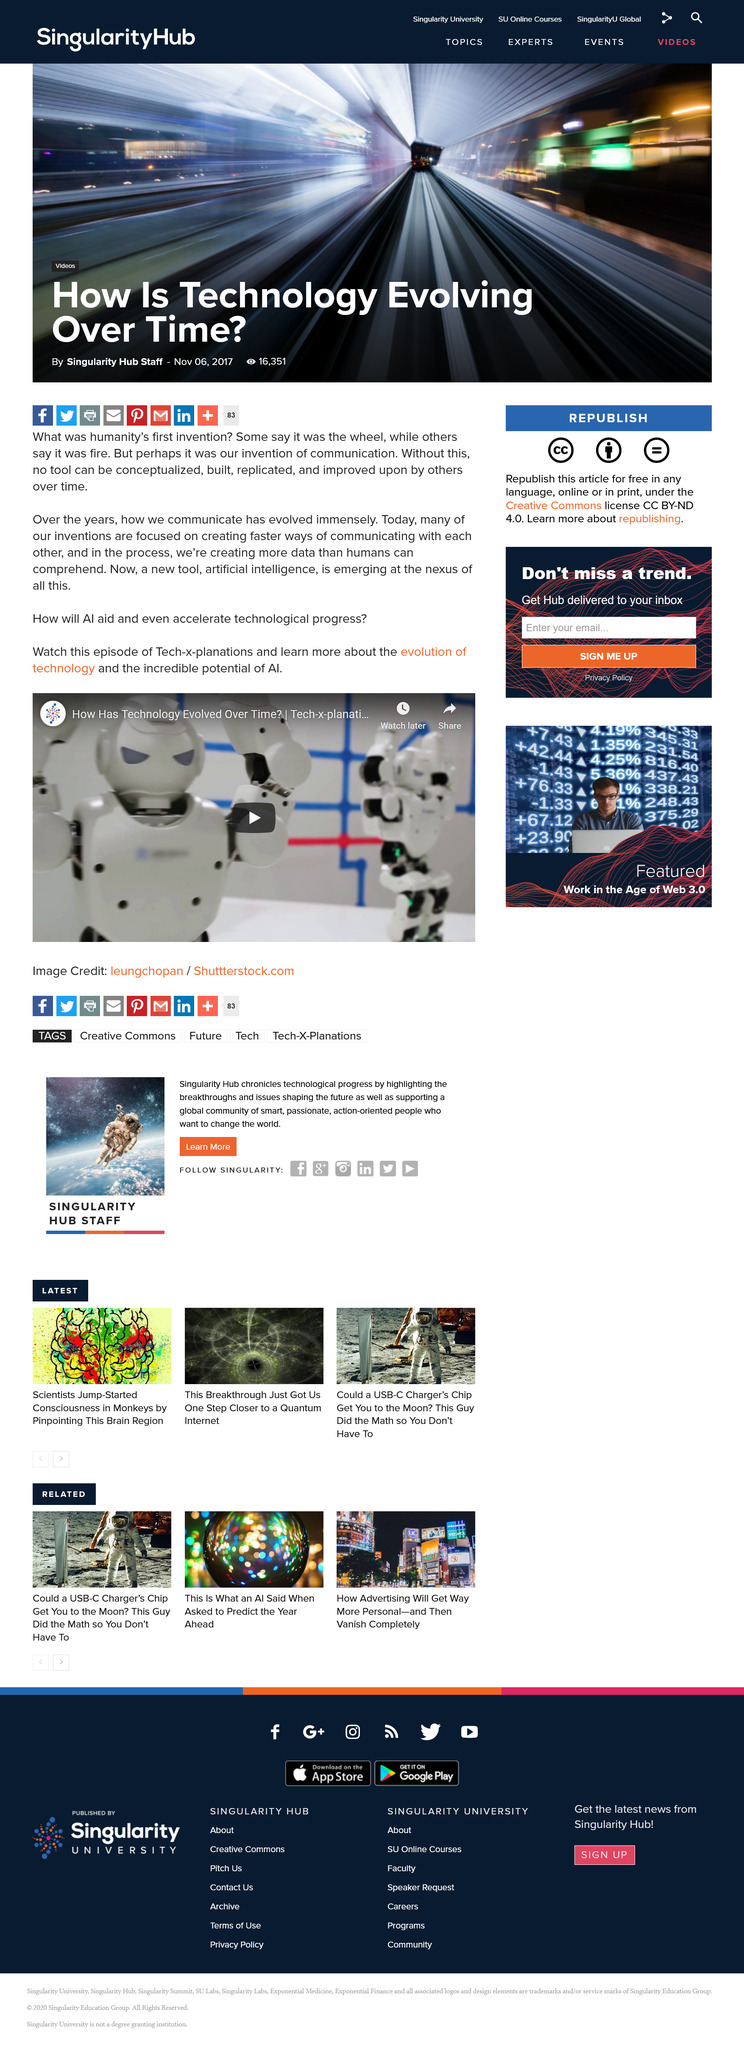Highlight a few significant elements in this photo. The show is called Tech-x-planations. An immense amount of data is created, surpassing human comprehension and ability to process it all. The new tool is called artificial intelligence. It is characterized by its ability to perform tasks that typically require human intelligence, such as visual perception, speech recognition, decision-making, and language translation. Artificial intelligence has numerous applications in various industries, including healthcare, finance, transportation, and manufacturing. It has the potential to revolutionize the way we live and work, making tasks more efficient, accurate, and accessible. 